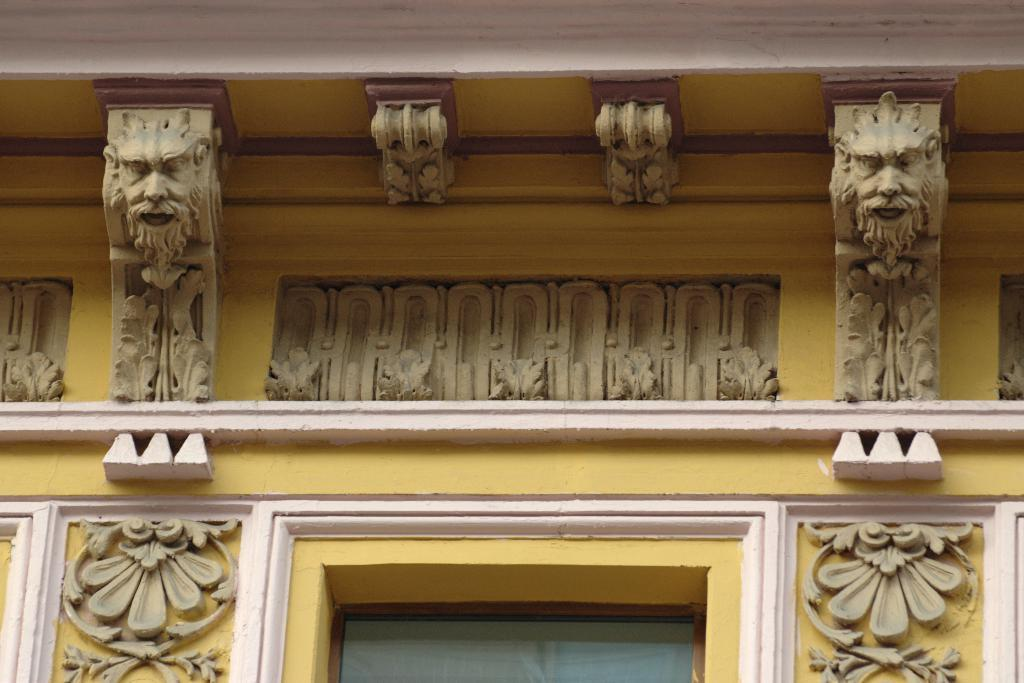What is the color of the building in the image? The building in the image is yellow. What decorative elements are present on the building? The building has sculptures on it. What type of nut can be seen falling from the building in the image? There is no nut present in the image, and therefore no such activity can be observed. 